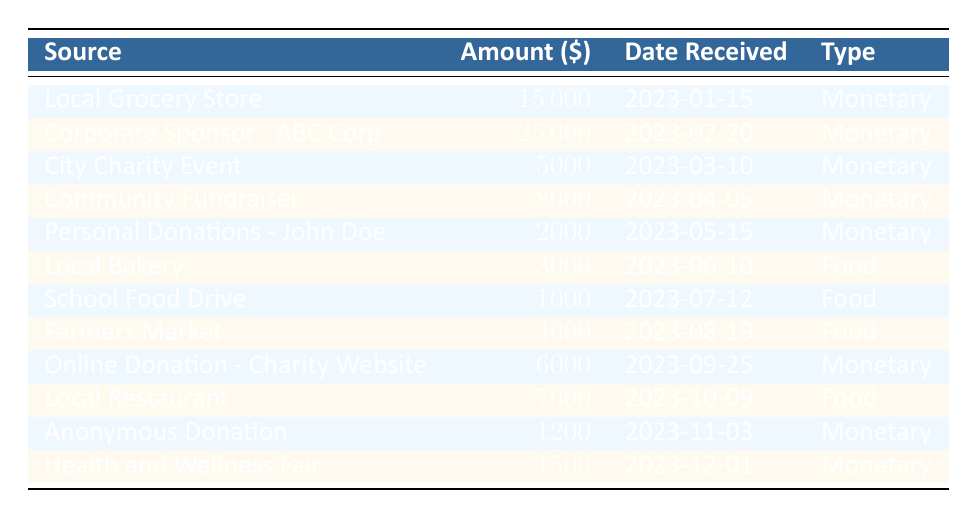What is the total amount received from monetary donations? To find the total amount from monetary donations, I add up all the amounts labeled as "monetary" in the table. The monetary donations are 15000 + 25000 + 5000 + 8000 + 2000 + 6000 + 1200 + 1500 = 58500.
Answer: 58500 Which source provided the highest amount of donation? I will review the "Amount" column for all the sources and identify the highest value. The highest value is 25000, which came from "Corporate Sponsor - ABC Corp."
Answer: Corporate Sponsor - ABC Corp Did the Local Bakery make a donation in 2023? I will check the table to see if "Local Bakery" appears as a source. The table confirms that the "Local Bakery" donated 3000 on June 10, 2023.
Answer: Yes What is the average amount received from food donations? I will first filter the food donations, which are 3000 (Local Bakery), 1000 (School Food Drive), 4000 (Farmers Market), and 7000 (Local Restaurant). The sum of these amounts is 3000 + 1000 + 4000 + 7000 = 15000. There are 4 food donations, so the average is 15000 divided by 4, which equals 3750.
Answer: 3750 How many unique sources contributed donations in 2023? I will count the number of different sources listed in the "Source" column. There are 12 unique sources: Local Grocery Store, Corporate Sponsor - ABC Corp, City Charity Event, Community Fundraiser, Personal Donations - John Doe, Local Bakery, School Food Drive, Farmers Market, Online Donation - Charity Website, Local Restaurant, Anonymous Donation, and Health and Wellness Fair.
Answer: 12 